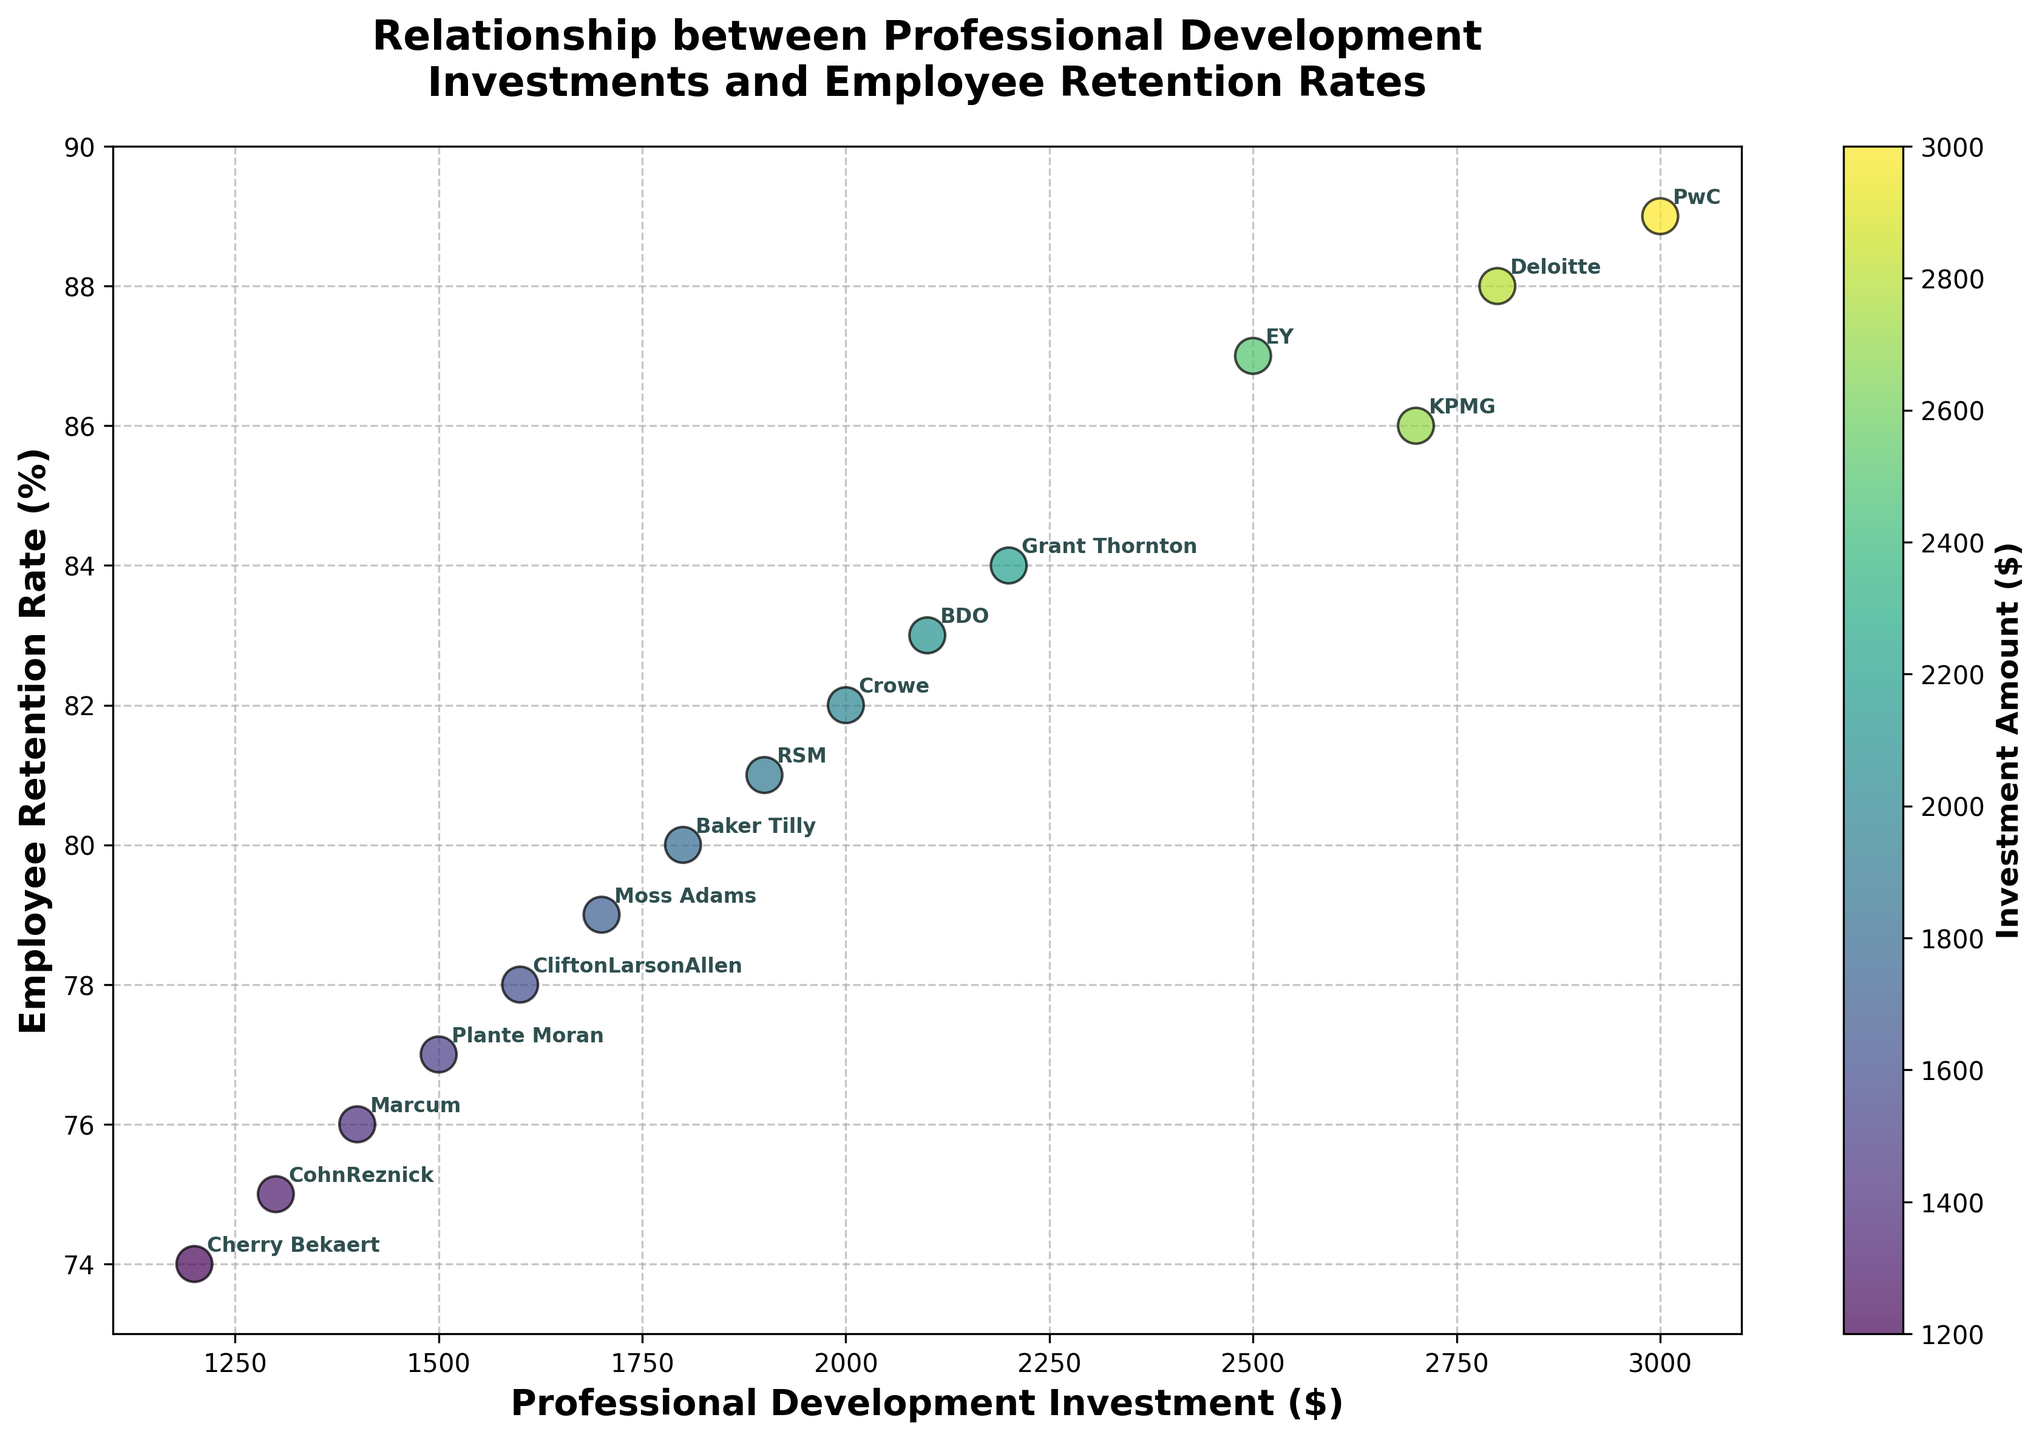What is the title of the plot? The title of the plot is located at the top center and provides a description of the plot. It reads "Relationship between Professional Development Investments and Employee Retention Rates".
Answer: Relationship between Professional Development Investments and Employee Retention Rates What is the color of the Crowe data point, and what does this color represent? The Crowe data point is colored using a gradient that represents the investment amount. Crowe is a lighter shade of green, indicating a lower investment compared to others.
Answer: Light green How many companies have an employee retention rate above 85%? By examining the y-axis, we identify which companies have points above the 85% mark. These companies include EY, PwC, Deloitte, and KPMG.
Answer: 4 Which company has the lowest professional development investment, and what is its employee retention rate? We look at the x-axis to determine which data point is farthest to the left. The lowest investment is $1200 by Cherry Bekaert, and its corresponding retention rate is 74%.
Answer: Cherry Bekaert with 74% By how much does PwC's investment exceed the investment of Grant Thornton? We find PwC's investment on the x-axis as $3000 and Grant Thornton's as $2200. Subtracting the latter from the former gives $3000 - $2200.
Answer: $800 Which company has the highest employee retention rate and what is its investment? The highest point on the y-axis indicates the highest retention rate, which is EY with a retention rate of 87% and an investment of $2500.
Answer: EY with $2500 What is the average professional development investment among all companies? Identify all investments (2500, 3000, 2800, 2700, 2200, 2100, 1900, 2000, 1800, 1700, 1600, 1500, 1400, 1300, 1200), sum them up, and divide by the number of companies. $\frac{2500+3000+2800+2700+2200+2100+1900+2000+1800+1700+1600+1500+1400+1300+1200}{15}$
Answer: $2040 Is there a positive correlation between professional development investment and employee retention rate? By observing the plot, it is evident that as the investment amount increases, the employee retention rate tends to increase as well, indicating a positive correlation.
Answer: Yes What is the difference in employee retention rate between Deloitte and CohnReznick, and how do their investments compare? Deloitte's retention rate is 88% and CohnReznick's is 75%. Subtracting gives 88% - 75% = 13%. Deloitte invests $2800, and CohnReznick invests $1300, so Deloitte invests more.
Answer: 13% difference, Deloitte invests more 